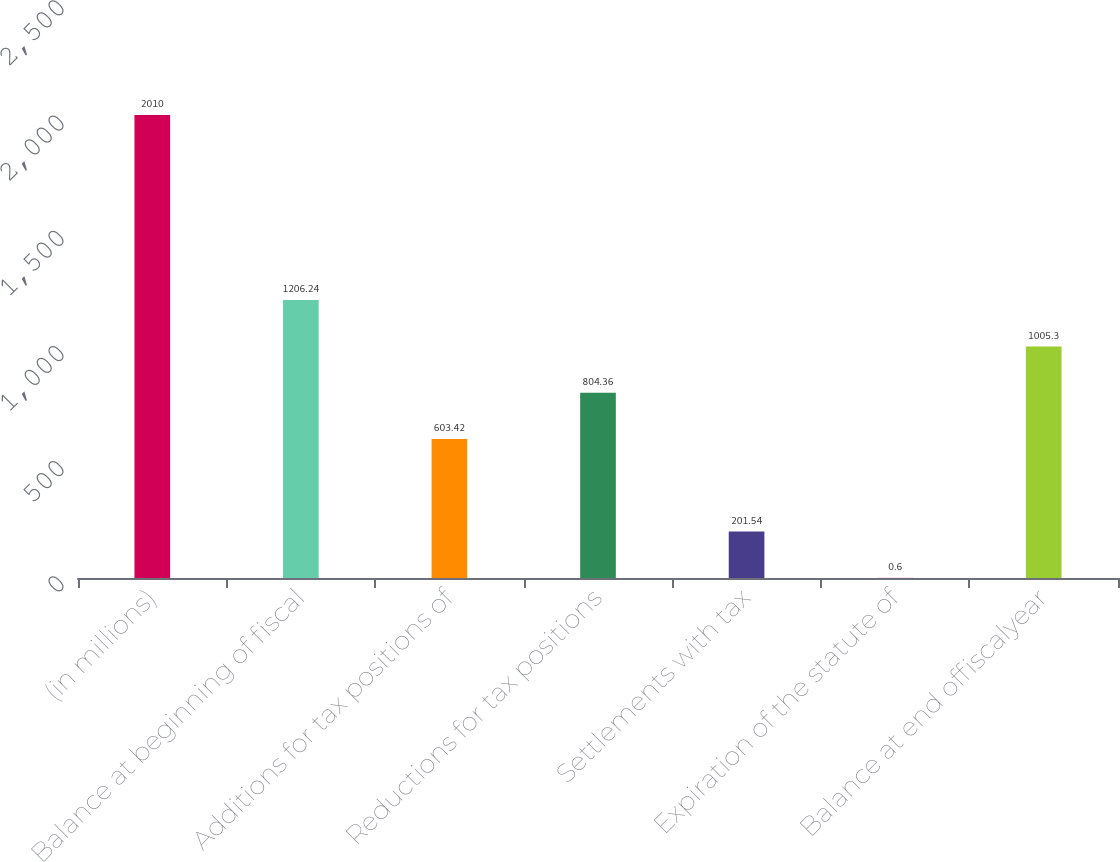<chart> <loc_0><loc_0><loc_500><loc_500><bar_chart><fcel>(in millions)<fcel>Balance at beginning of fiscal<fcel>Additions for tax positions of<fcel>Reductions for tax positions<fcel>Settlements with tax<fcel>Expiration of the statute of<fcel>Balance at end offiscalyear<nl><fcel>2010<fcel>1206.24<fcel>603.42<fcel>804.36<fcel>201.54<fcel>0.6<fcel>1005.3<nl></chart> 